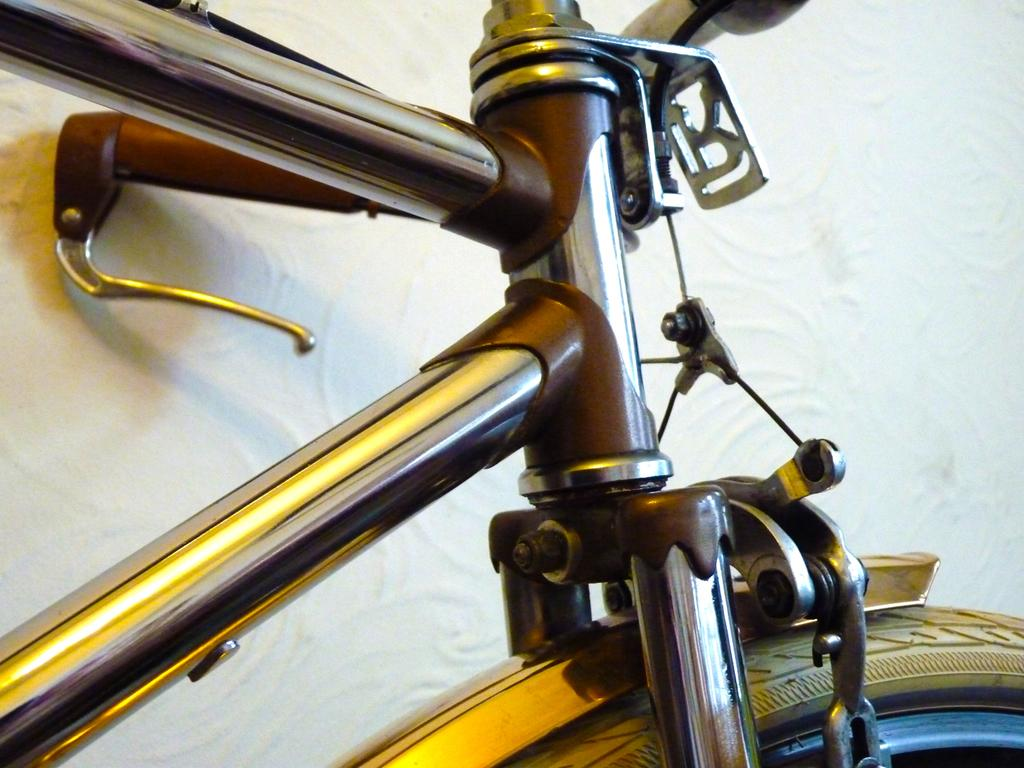What is the main subject in the foreground of the image? There is a cycle in the foreground of the image. What can be seen in the background of the image? There is a wall in the background of the image. What type of hat is the cycle wearing in the image? There is no hat present in the image, as cycles do not wear hats. 